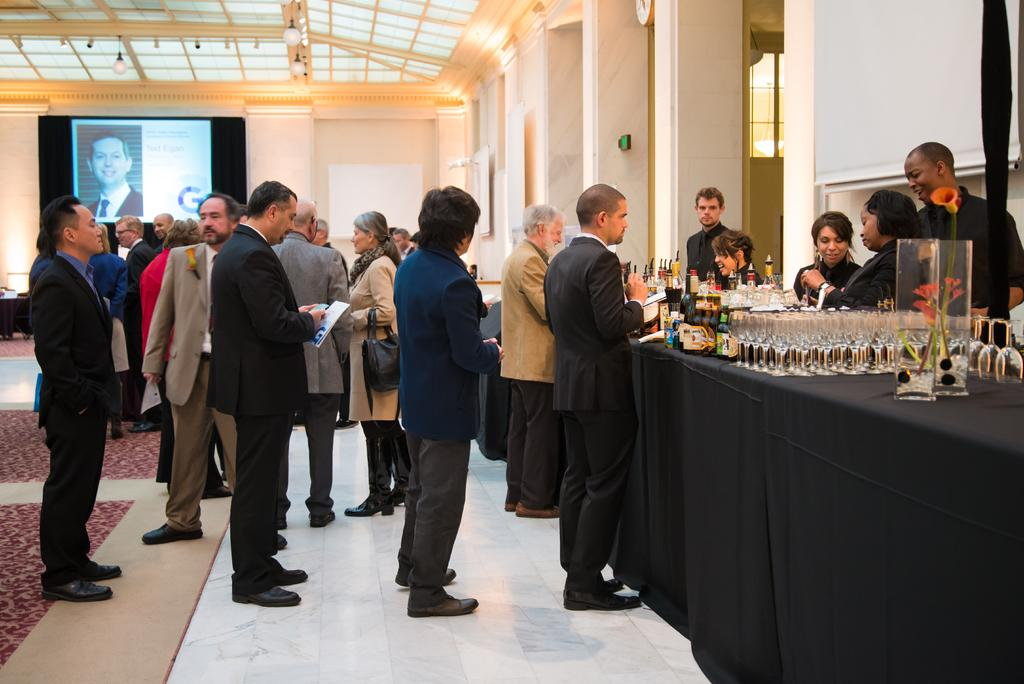What can be seen in the image? There are people standing in the image, along with a table, glasses, wine bottles, a wall, and a screen in the background. What is on the table? There are glasses and wine bottles on the table. What is visible in the background of the image? There is a wall and a screen in the background of the image. What caption is written on the glasses in the image? There is no caption written on the glasses in the image. How many visitors are present in the image? The term "visitors" is not mentioned in the provided facts, so we cannot determine the number of visitors in the image. 